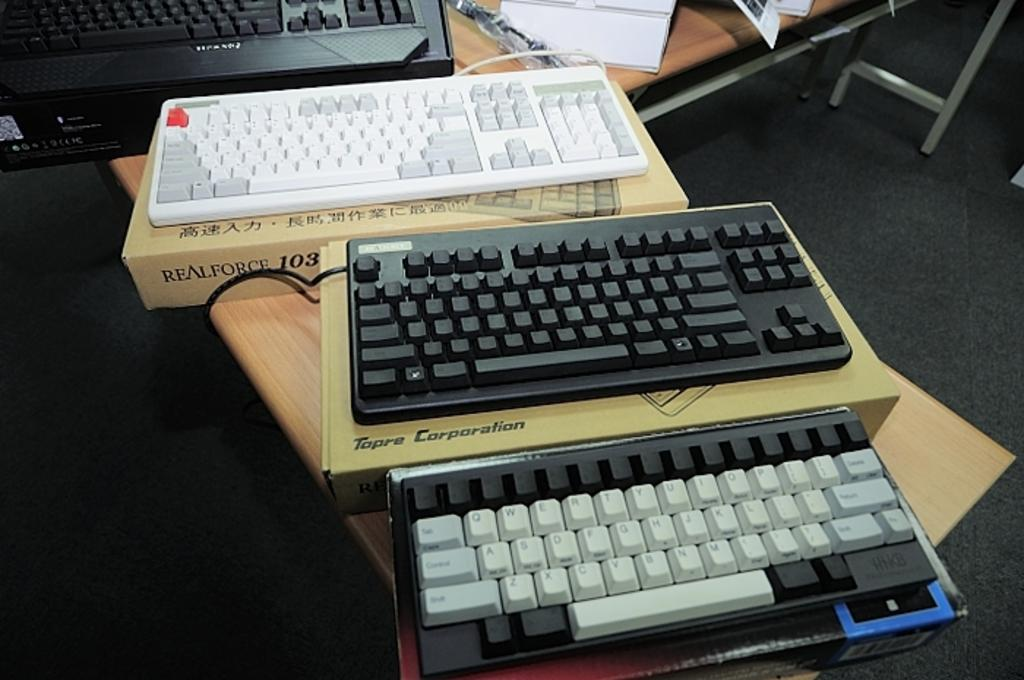What is the main piece of furniture in the image? There is a table in the image. What items are placed on the table? There are three keyboards on the table, as well as boxes of keyboards. What can be seen in the background of the image? In the background, there are more keyboards and papers visible. Is there any other furniture or equipment in the background? Yes, there is a stand in the background. Can you see the ocean in the background of the image? No, the ocean is not present in the image; it features a table, keyboards, boxes, papers, and a stand. How many ladybugs are crawling on the keyboards in the image? There are no ladybugs visible in the image; it only features keyboards, boxes, papers, and a stand. 